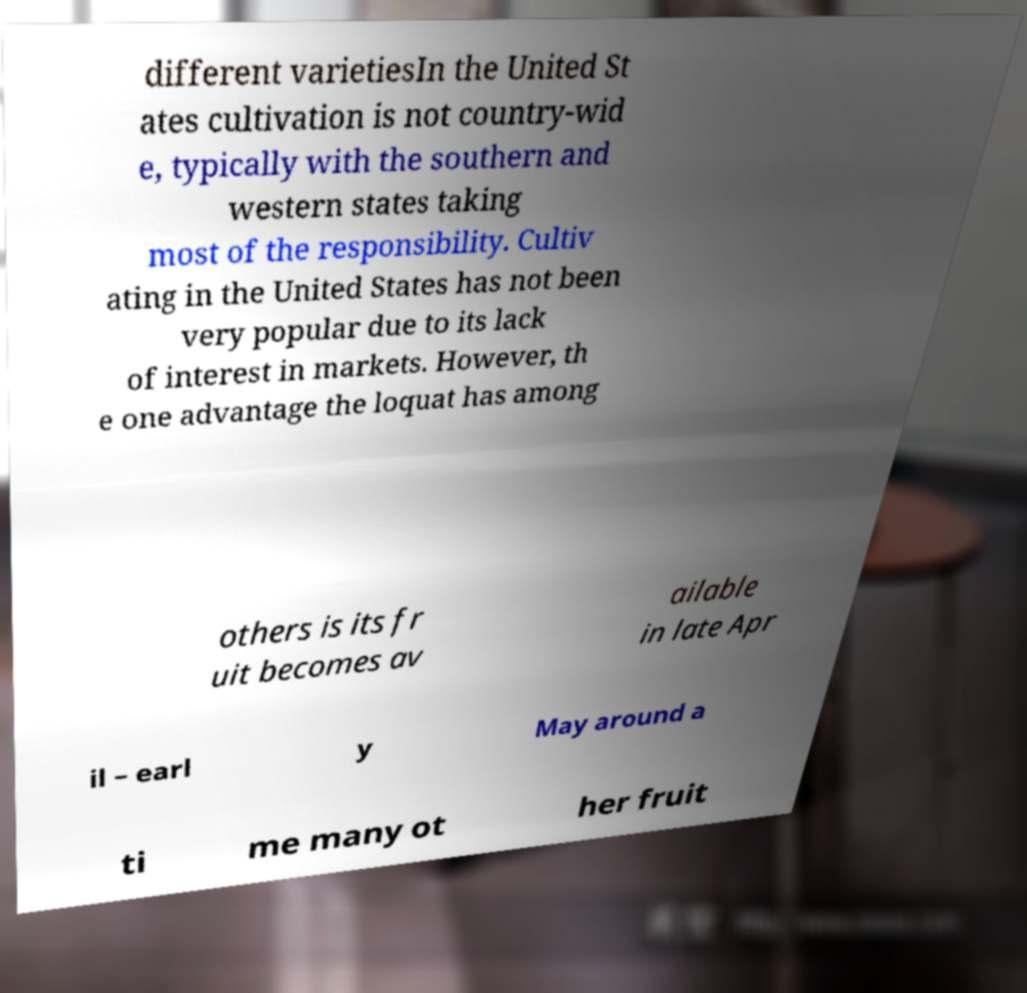Can you accurately transcribe the text from the provided image for me? different varietiesIn the United St ates cultivation is not country-wid e, typically with the southern and western states taking most of the responsibility. Cultiv ating in the United States has not been very popular due to its lack of interest in markets. However, th e one advantage the loquat has among others is its fr uit becomes av ailable in late Apr il – earl y May around a ti me many ot her fruit 